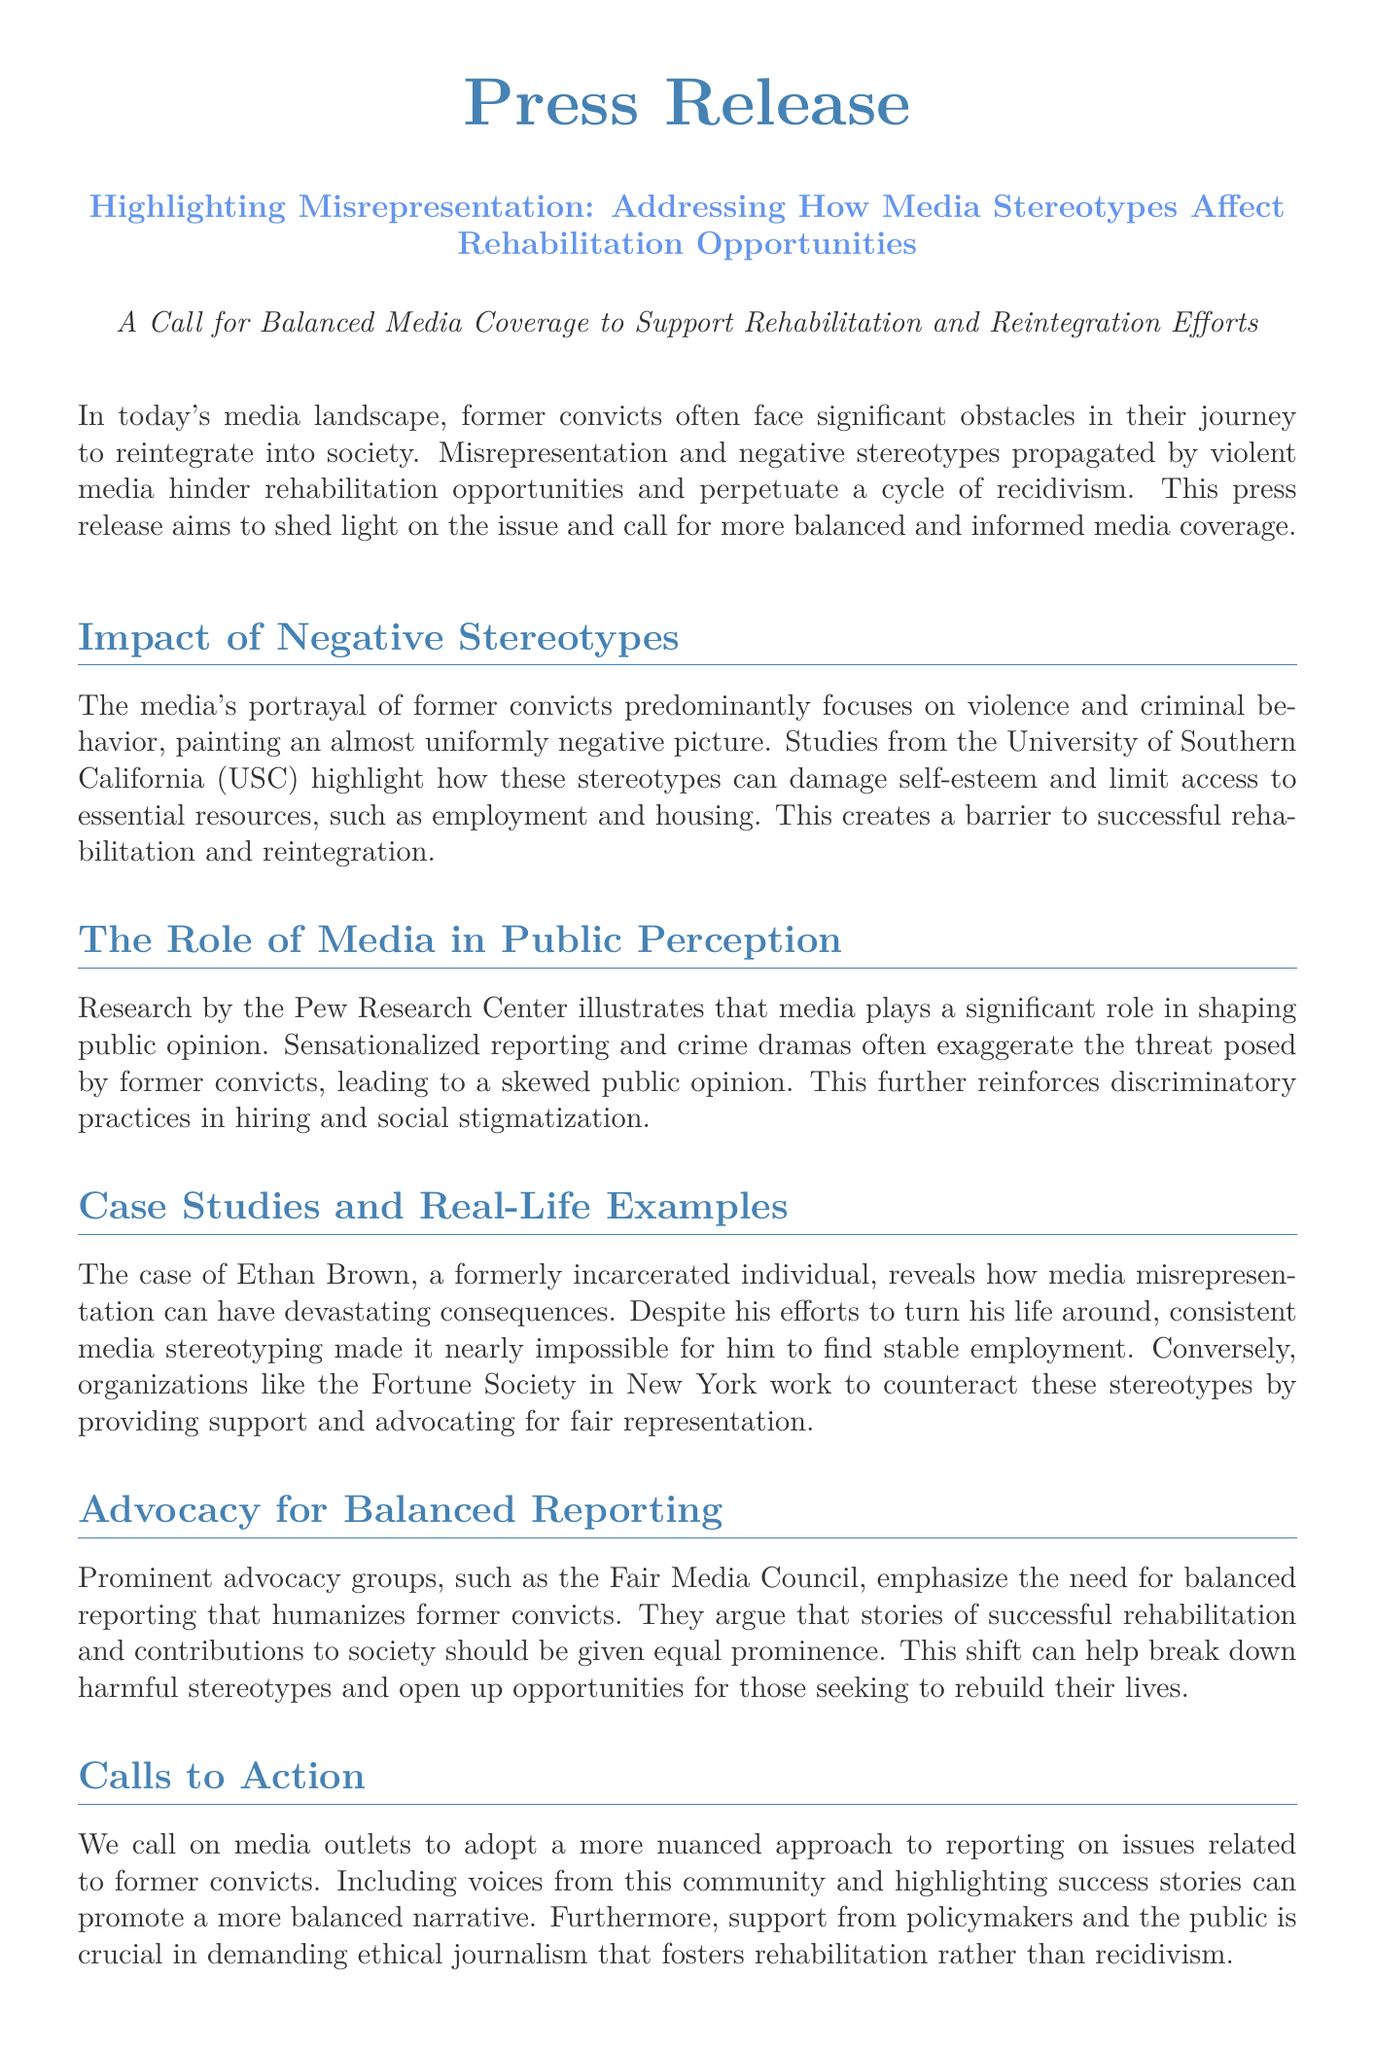What is the title of the press release? The title is found at the beginning of the document, stating the main topic of discussion.
Answer: Highlighting Misrepresentation: Addressing How Media Stereotypes Affect Rehabilitation Opportunities What organization conducted studies on stereotypes? The document mentions the organization that provided evidence regarding stereotypes affecting former convicts.
Answer: University of Southern California What is the primary issue addressed in the press release? The press release outlines the main challenge faced by former convicts in society.
Answer: Misrepresentation and negative stereotypes Who is mentioned as a case study in the document? The press release includes a specific example of an individual affected by media stereotypes.
Answer: Ethan Brown Which advocacy group is highlighted in the press release? The document names a prominent group advocating for balanced media representation.
Answer: Fair Media Council What should media outlets include to promote a balanced narrative? The press release calls upon media outlets to amplify certain aspects in their reporting.
Answer: Voices from this community and highlighting success stories What is the suggested approach for media reporting? The press release advocates for a particular method of storytelling in the media.
Answer: Nuanced approach Which center conducted research on media's role in public perception? The document specifies the institution that studied public opinion related to media.
Answer: Pew Research Center 